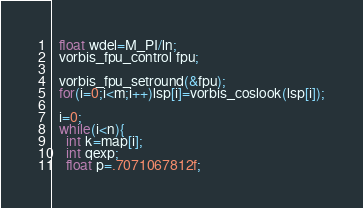<code> <loc_0><loc_0><loc_500><loc_500><_C_>  float wdel=M_PI/ln;
  vorbis_fpu_control fpu;
  
  vorbis_fpu_setround(&fpu);
  for(i=0;i<m;i++)lsp[i]=vorbis_coslook(lsp[i]);

  i=0;
  while(i<n){
    int k=map[i];
    int qexp;
    float p=.7071067812f;</code> 